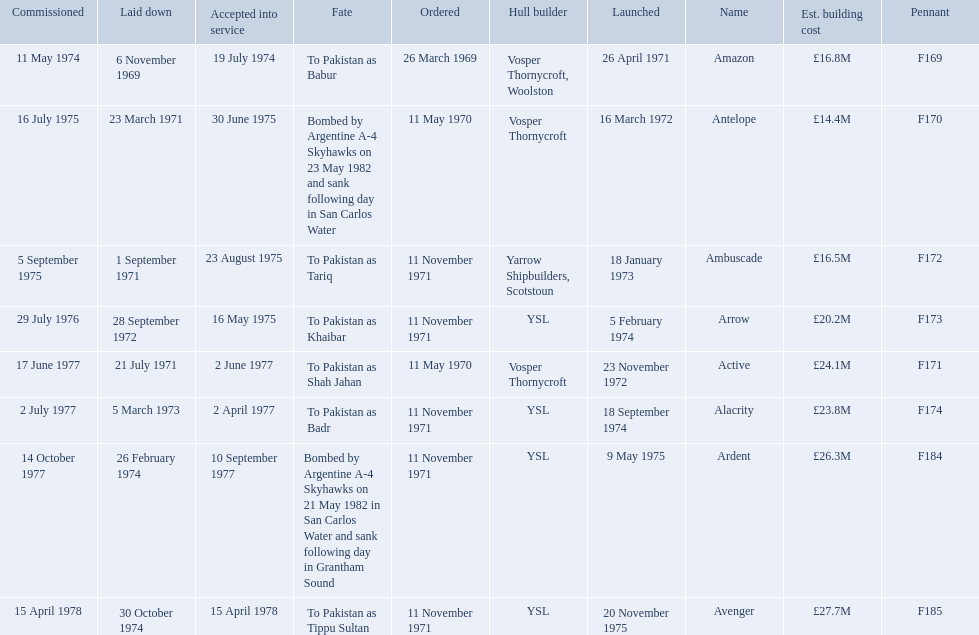Which type 21 frigate ships were to be built by ysl in the 1970s? Arrow, Alacrity, Ardent, Avenger. Of these ships, which one had the highest estimated building cost? Avenger. 